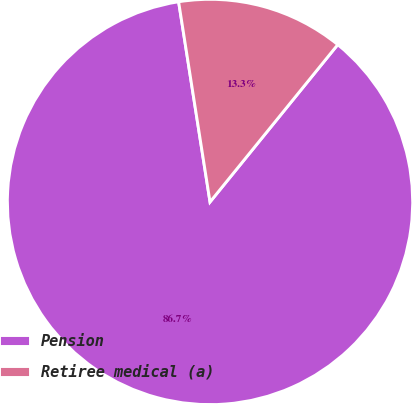Convert chart. <chart><loc_0><loc_0><loc_500><loc_500><pie_chart><fcel>Pension<fcel>Retiree medical (a)<nl><fcel>86.67%<fcel>13.33%<nl></chart> 